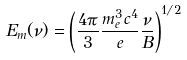<formula> <loc_0><loc_0><loc_500><loc_500>E _ { m } ( \nu ) = \left ( \frac { 4 \pi } { 3 } \frac { m _ { e } ^ { 3 } c ^ { 4 } } { e } \frac { \nu } { B } \right ) ^ { 1 / 2 }</formula> 